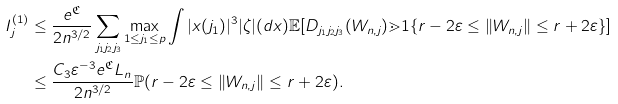<formula> <loc_0><loc_0><loc_500><loc_500>I _ { j } ^ { ( 1 ) } & \leq \frac { e ^ { \mathfrak { C } } } { 2 n ^ { 3 / 2 } } \sum _ { j _ { 1 } j _ { 2 } j _ { 3 } } \max _ { 1 \leq j _ { 1 } \leq p } \int | x ( j _ { 1 } ) | ^ { 3 } | \zeta | ( d x ) \mathbb { E } [ D _ { j _ { 1 } j _ { 2 } j _ { 3 } } ( W _ { n , j } ) \mathbb { m } { 1 } \{ r - 2 \varepsilon \leq \| W _ { n , j } \| \leq r + 2 \varepsilon \} ] \\ & \leq \frac { C _ { 3 } \varepsilon ^ { - 3 } e ^ { \mathfrak { C } } L _ { n } } { 2 n ^ { 3 / 2 } } \mathbb { P } ( r - 2 \varepsilon \leq \| W _ { n , j } \| \leq r + 2 \varepsilon ) .</formula> 